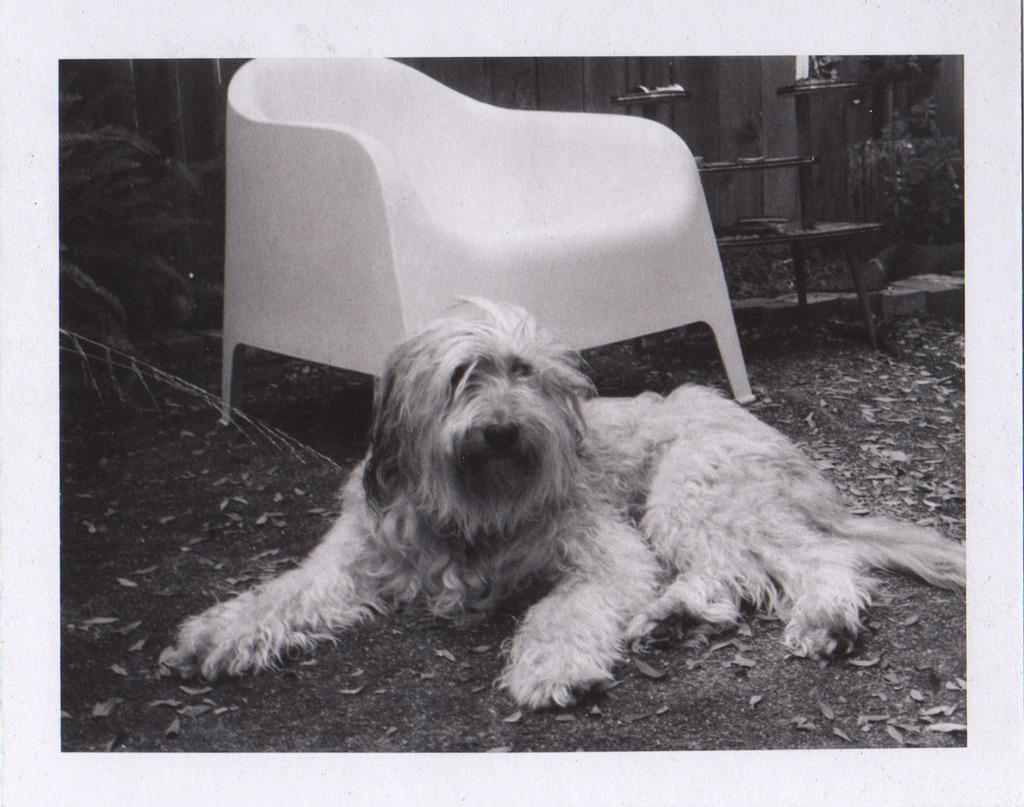What is the color scheme of the image? The image is black and white. What object can be seen in the middle of the image? There is a chair in the middle of the image. What living creature is also present in the middle of the image? There is a dog in the middle of the image. What type of yam is being used as a headrest for the dog in the image? There is no yam present in the image, and the dog is not using any object as a headrest. 